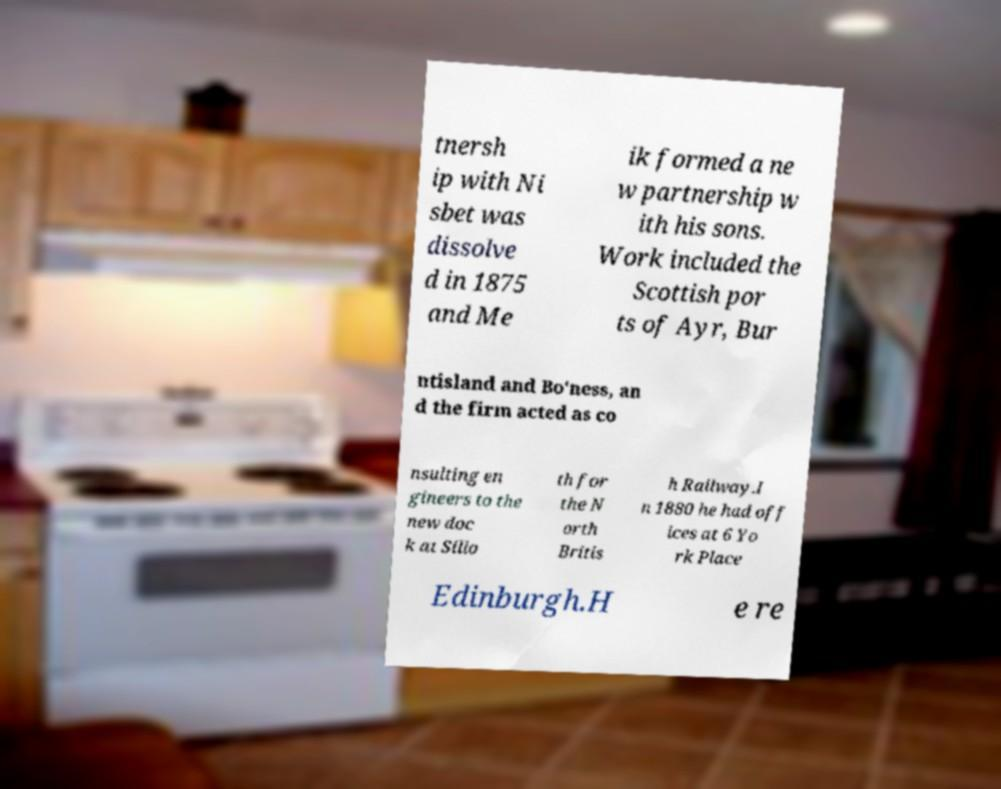Can you accurately transcribe the text from the provided image for me? tnersh ip with Ni sbet was dissolve d in 1875 and Me ik formed a ne w partnership w ith his sons. Work included the Scottish por ts of Ayr, Bur ntisland and Bo'ness, an d the firm acted as co nsulting en gineers to the new doc k at Sillo th for the N orth Britis h Railway.I n 1880 he had off ices at 6 Yo rk Place Edinburgh.H e re 